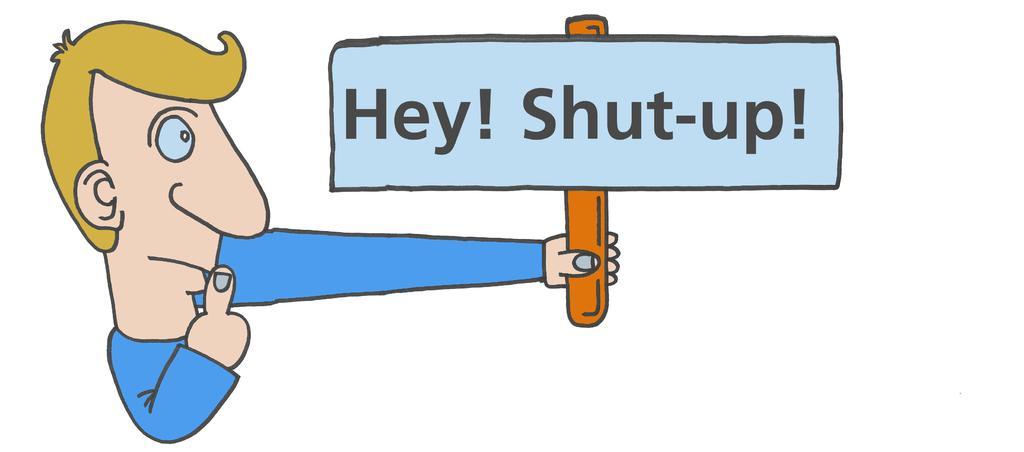Please provide a concise description of this image. It is an animated image of a man holding a board, Hey shut up! 